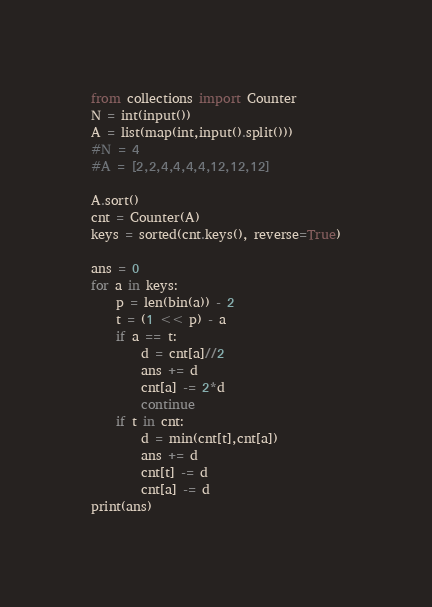<code> <loc_0><loc_0><loc_500><loc_500><_Python_>from collections import Counter
N = int(input())
A = list(map(int,input().split()))
#N = 4
#A = [2,2,4,4,4,4,12,12,12]

A.sort()
cnt = Counter(A)
keys = sorted(cnt.keys(), reverse=True)

ans = 0
for a in keys:
    p = len(bin(a)) - 2
    t = (1 << p) - a
    if a == t:
        d = cnt[a]//2
        ans += d
        cnt[a] -= 2*d
        continue
    if t in cnt:
        d = min(cnt[t],cnt[a])
        ans += d
        cnt[t] -= d
        cnt[a] -= d
print(ans)



</code> 